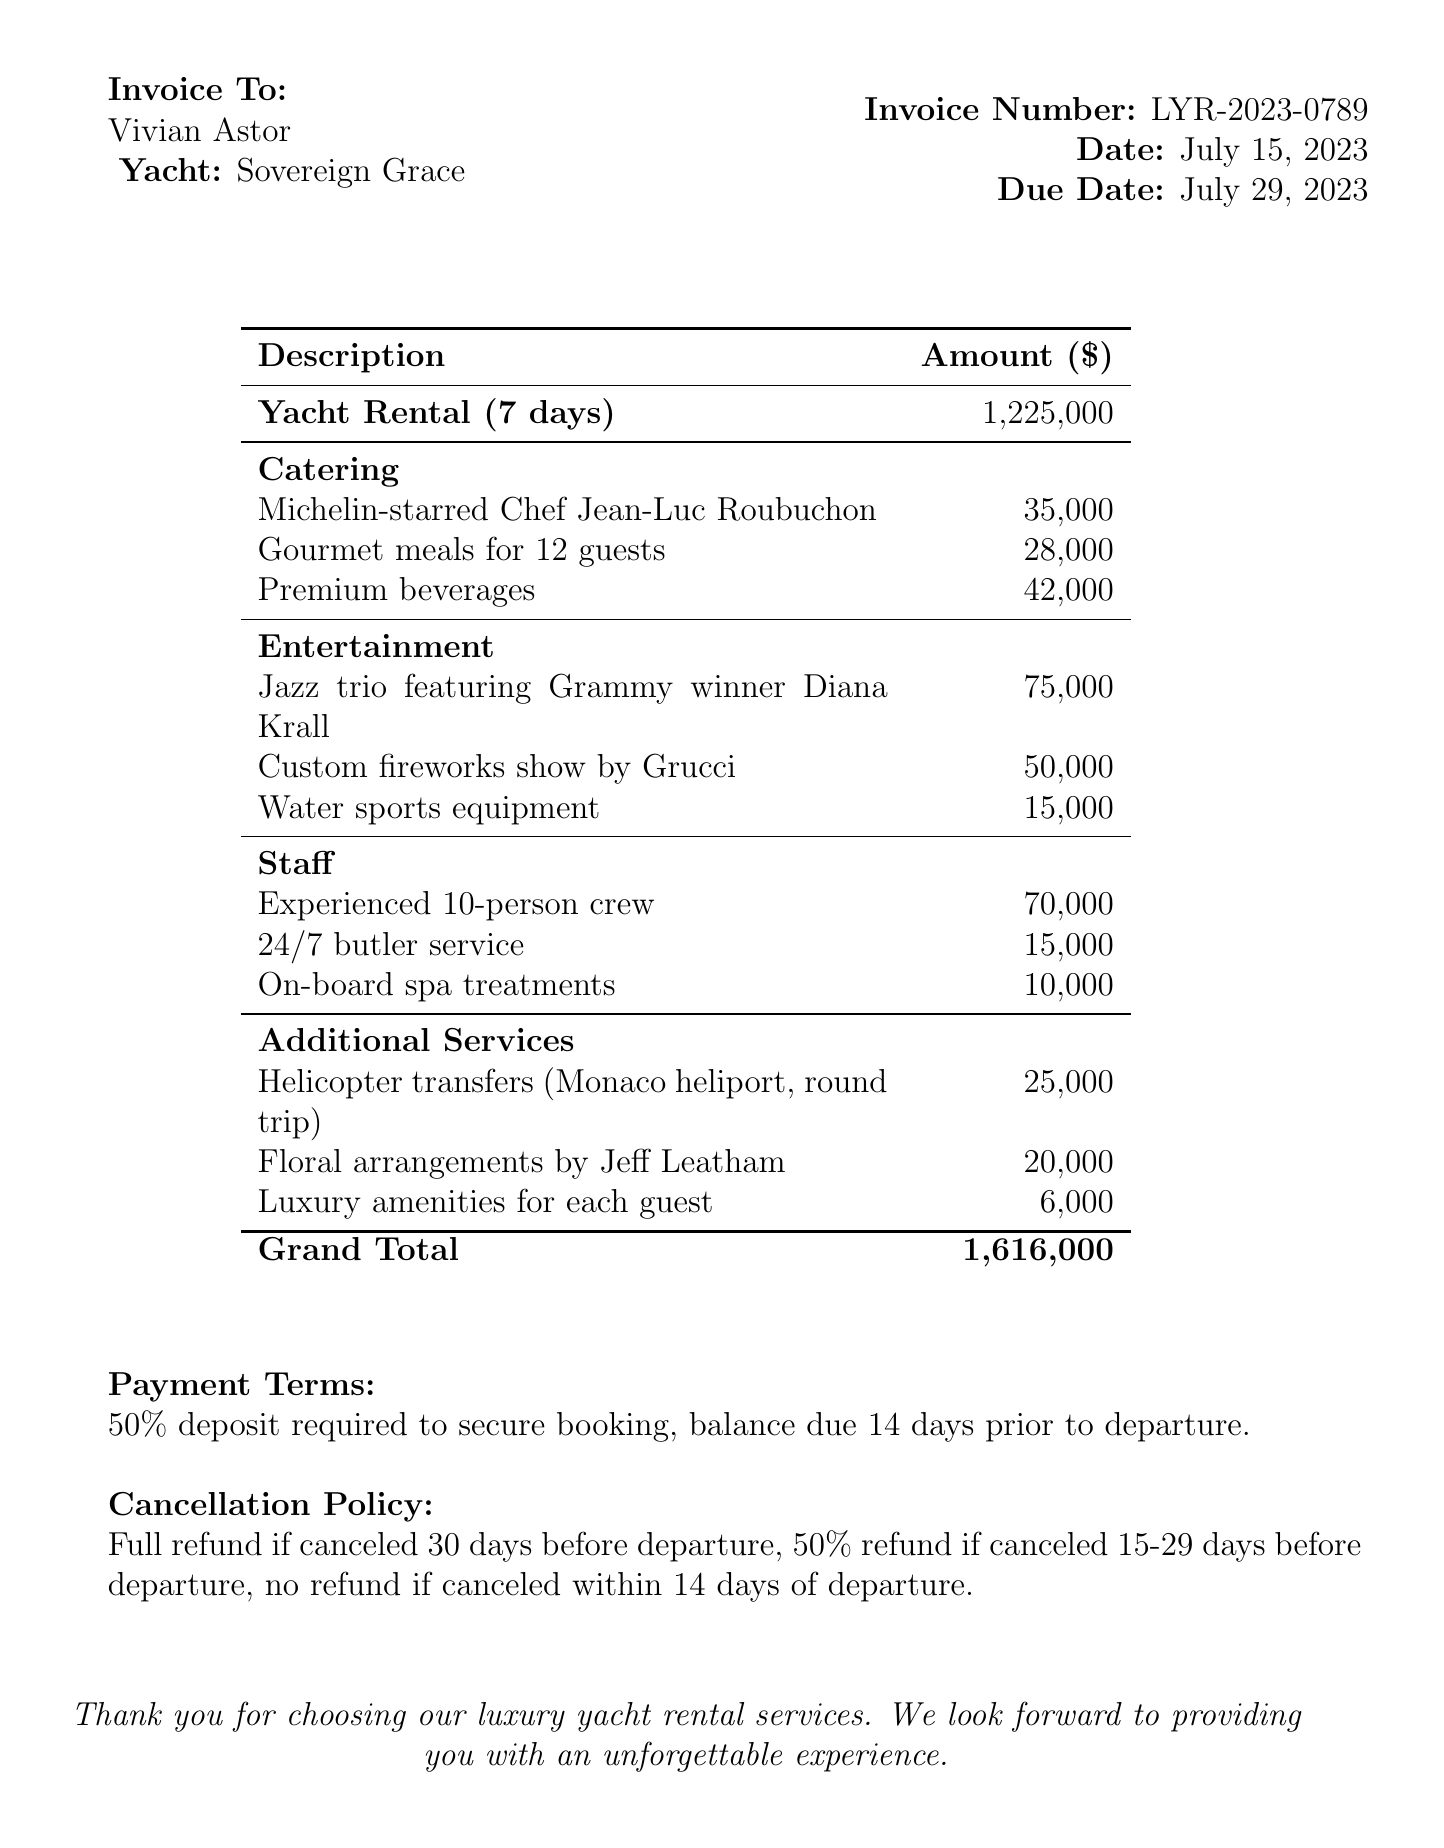What is the invoice number? The invoice number is specified on the document in the invoice details section.
Answer: LYR-2023-0789 What is the date of the invoice? The date is listed in the invoice details section.
Answer: July 15, 2023 Who is the client? The name of the client is included in the invoice details section.
Answer: Vivian Astor What is the total cost for catering? The total caterings services cost is itemized in the catering section of the document.
Answer: 105000 What is the cost for the live music entertainment? The cost for the live music is provided in the entertainment section of the invoice.
Answer: 75000 How many days is the yacht rented for? The rental duration is specified in the yacht rental section of the document.
Answer: 7 days What are the payment terms? The payment terms describe the requirements for securing the booking found at the bottom of the document.
Answer: 50% deposit required to secure booking, balance due 14 days prior to departure What is the grand total for the invoice? The grand total is calculated and listed at the bottom of the cost breakdown.
Answer: 1616000 What is the cancellation policy for this rental? The cancellation policy outlines the refund conditions if canceled and is found at the end of the document.
Answer: Full refund if canceled 30 days before departure, 50% refund if canceled 15-29 days before departure, no refund if canceled within 14 days of departure 